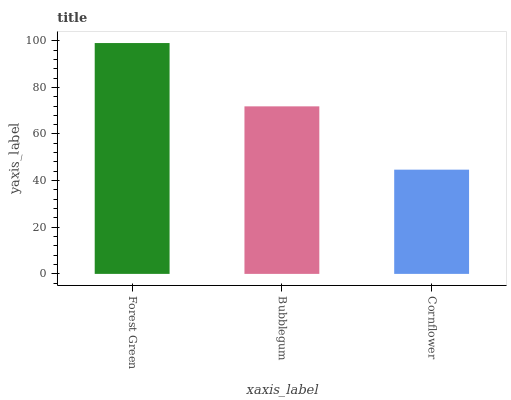Is Cornflower the minimum?
Answer yes or no. Yes. Is Forest Green the maximum?
Answer yes or no. Yes. Is Bubblegum the minimum?
Answer yes or no. No. Is Bubblegum the maximum?
Answer yes or no. No. Is Forest Green greater than Bubblegum?
Answer yes or no. Yes. Is Bubblegum less than Forest Green?
Answer yes or no. Yes. Is Bubblegum greater than Forest Green?
Answer yes or no. No. Is Forest Green less than Bubblegum?
Answer yes or no. No. Is Bubblegum the high median?
Answer yes or no. Yes. Is Bubblegum the low median?
Answer yes or no. Yes. Is Cornflower the high median?
Answer yes or no. No. Is Cornflower the low median?
Answer yes or no. No. 